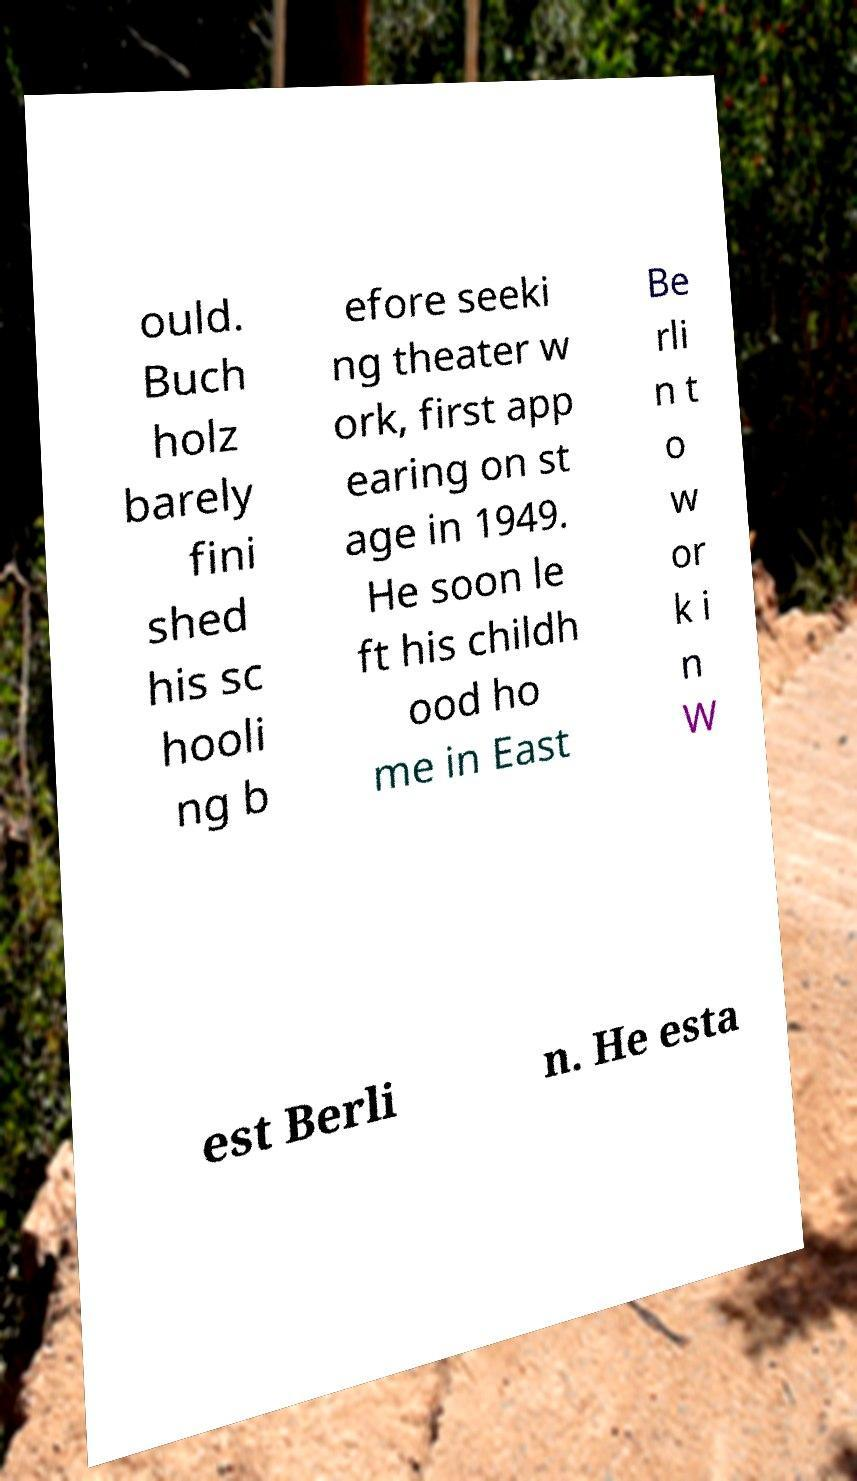Could you assist in decoding the text presented in this image and type it out clearly? ould. Buch holz barely fini shed his sc hooli ng b efore seeki ng theater w ork, first app earing on st age in 1949. He soon le ft his childh ood ho me in East Be rli n t o w or k i n W est Berli n. He esta 